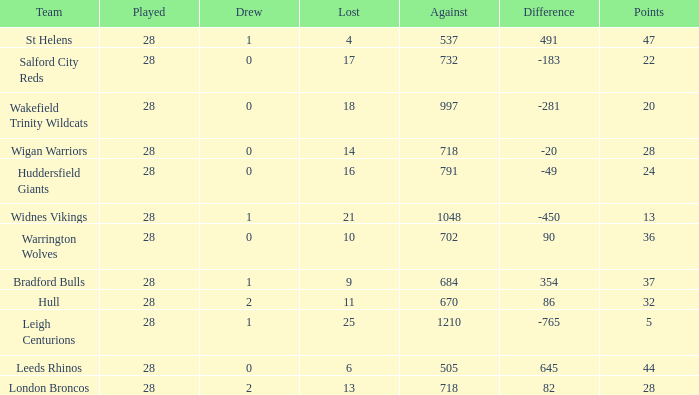What is the average points for a team that lost 4 and played more than 28 games? None. 